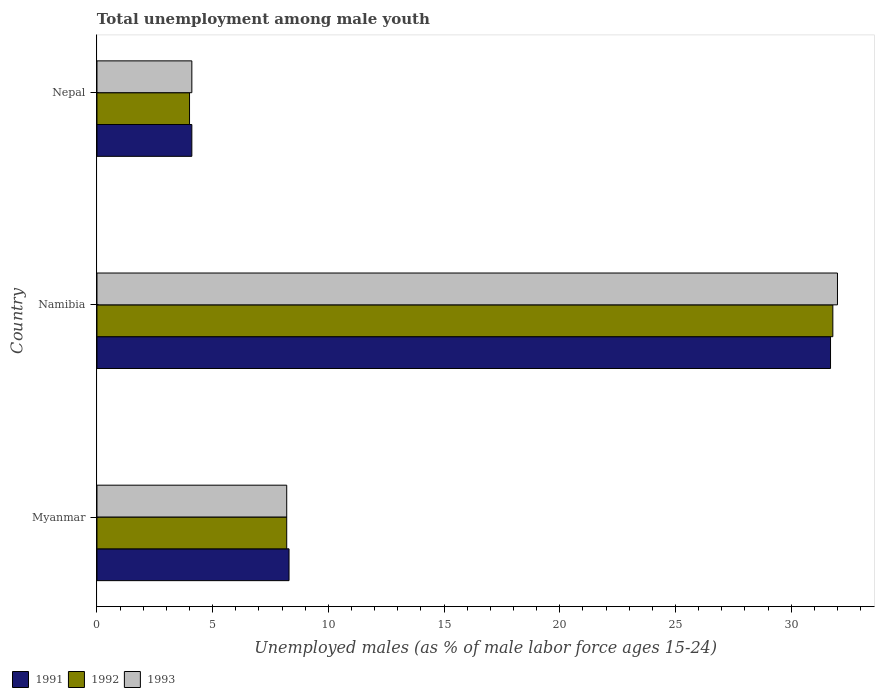How many groups of bars are there?
Your response must be concise. 3. Are the number of bars per tick equal to the number of legend labels?
Offer a very short reply. Yes. Are the number of bars on each tick of the Y-axis equal?
Provide a short and direct response. Yes. How many bars are there on the 2nd tick from the top?
Provide a succinct answer. 3. What is the label of the 2nd group of bars from the top?
Keep it short and to the point. Namibia. What is the percentage of unemployed males in in 1993 in Namibia?
Make the answer very short. 32. Across all countries, what is the minimum percentage of unemployed males in in 1991?
Offer a terse response. 4.1. In which country was the percentage of unemployed males in in 1992 maximum?
Make the answer very short. Namibia. In which country was the percentage of unemployed males in in 1993 minimum?
Give a very brief answer. Nepal. What is the total percentage of unemployed males in in 1991 in the graph?
Ensure brevity in your answer.  44.1. What is the difference between the percentage of unemployed males in in 1991 in Myanmar and that in Nepal?
Offer a terse response. 4.2. What is the difference between the percentage of unemployed males in in 1992 in Namibia and the percentage of unemployed males in in 1993 in Myanmar?
Offer a very short reply. 23.6. What is the average percentage of unemployed males in in 1993 per country?
Ensure brevity in your answer.  14.77. What is the difference between the percentage of unemployed males in in 1992 and percentage of unemployed males in in 1993 in Myanmar?
Ensure brevity in your answer.  0. In how many countries, is the percentage of unemployed males in in 1991 greater than 28 %?
Keep it short and to the point. 1. What is the ratio of the percentage of unemployed males in in 1992 in Myanmar to that in Nepal?
Offer a terse response. 2.05. What is the difference between the highest and the second highest percentage of unemployed males in in 1992?
Make the answer very short. 23.6. What is the difference between the highest and the lowest percentage of unemployed males in in 1992?
Provide a succinct answer. 27.8. Is the sum of the percentage of unemployed males in in 1992 in Namibia and Nepal greater than the maximum percentage of unemployed males in in 1993 across all countries?
Your response must be concise. Yes. What does the 3rd bar from the top in Namibia represents?
Offer a terse response. 1991. What does the 1st bar from the bottom in Namibia represents?
Your answer should be very brief. 1991. How many bars are there?
Your response must be concise. 9. How many countries are there in the graph?
Offer a very short reply. 3. Are the values on the major ticks of X-axis written in scientific E-notation?
Provide a short and direct response. No. Does the graph contain any zero values?
Ensure brevity in your answer.  No. Does the graph contain grids?
Provide a succinct answer. No. How many legend labels are there?
Provide a short and direct response. 3. How are the legend labels stacked?
Make the answer very short. Horizontal. What is the title of the graph?
Ensure brevity in your answer.  Total unemployment among male youth. Does "1990" appear as one of the legend labels in the graph?
Offer a very short reply. No. What is the label or title of the X-axis?
Provide a succinct answer. Unemployed males (as % of male labor force ages 15-24). What is the Unemployed males (as % of male labor force ages 15-24) of 1991 in Myanmar?
Your answer should be compact. 8.3. What is the Unemployed males (as % of male labor force ages 15-24) of 1992 in Myanmar?
Make the answer very short. 8.2. What is the Unemployed males (as % of male labor force ages 15-24) in 1993 in Myanmar?
Provide a short and direct response. 8.2. What is the Unemployed males (as % of male labor force ages 15-24) of 1991 in Namibia?
Your answer should be compact. 31.7. What is the Unemployed males (as % of male labor force ages 15-24) of 1992 in Namibia?
Provide a succinct answer. 31.8. What is the Unemployed males (as % of male labor force ages 15-24) of 1991 in Nepal?
Offer a terse response. 4.1. What is the Unemployed males (as % of male labor force ages 15-24) of 1993 in Nepal?
Keep it short and to the point. 4.1. Across all countries, what is the maximum Unemployed males (as % of male labor force ages 15-24) of 1991?
Give a very brief answer. 31.7. Across all countries, what is the maximum Unemployed males (as % of male labor force ages 15-24) in 1992?
Your response must be concise. 31.8. Across all countries, what is the maximum Unemployed males (as % of male labor force ages 15-24) of 1993?
Keep it short and to the point. 32. Across all countries, what is the minimum Unemployed males (as % of male labor force ages 15-24) in 1991?
Your answer should be very brief. 4.1. Across all countries, what is the minimum Unemployed males (as % of male labor force ages 15-24) in 1993?
Make the answer very short. 4.1. What is the total Unemployed males (as % of male labor force ages 15-24) of 1991 in the graph?
Provide a short and direct response. 44.1. What is the total Unemployed males (as % of male labor force ages 15-24) of 1992 in the graph?
Keep it short and to the point. 44. What is the total Unemployed males (as % of male labor force ages 15-24) of 1993 in the graph?
Your answer should be very brief. 44.3. What is the difference between the Unemployed males (as % of male labor force ages 15-24) in 1991 in Myanmar and that in Namibia?
Provide a short and direct response. -23.4. What is the difference between the Unemployed males (as % of male labor force ages 15-24) of 1992 in Myanmar and that in Namibia?
Your answer should be very brief. -23.6. What is the difference between the Unemployed males (as % of male labor force ages 15-24) of 1993 in Myanmar and that in Namibia?
Your answer should be compact. -23.8. What is the difference between the Unemployed males (as % of male labor force ages 15-24) in 1992 in Myanmar and that in Nepal?
Your response must be concise. 4.2. What is the difference between the Unemployed males (as % of male labor force ages 15-24) in 1993 in Myanmar and that in Nepal?
Offer a terse response. 4.1. What is the difference between the Unemployed males (as % of male labor force ages 15-24) in 1991 in Namibia and that in Nepal?
Your response must be concise. 27.6. What is the difference between the Unemployed males (as % of male labor force ages 15-24) of 1992 in Namibia and that in Nepal?
Make the answer very short. 27.8. What is the difference between the Unemployed males (as % of male labor force ages 15-24) of 1993 in Namibia and that in Nepal?
Ensure brevity in your answer.  27.9. What is the difference between the Unemployed males (as % of male labor force ages 15-24) in 1991 in Myanmar and the Unemployed males (as % of male labor force ages 15-24) in 1992 in Namibia?
Provide a succinct answer. -23.5. What is the difference between the Unemployed males (as % of male labor force ages 15-24) of 1991 in Myanmar and the Unemployed males (as % of male labor force ages 15-24) of 1993 in Namibia?
Provide a short and direct response. -23.7. What is the difference between the Unemployed males (as % of male labor force ages 15-24) of 1992 in Myanmar and the Unemployed males (as % of male labor force ages 15-24) of 1993 in Namibia?
Make the answer very short. -23.8. What is the difference between the Unemployed males (as % of male labor force ages 15-24) of 1991 in Myanmar and the Unemployed males (as % of male labor force ages 15-24) of 1992 in Nepal?
Make the answer very short. 4.3. What is the difference between the Unemployed males (as % of male labor force ages 15-24) in 1992 in Myanmar and the Unemployed males (as % of male labor force ages 15-24) in 1993 in Nepal?
Your response must be concise. 4.1. What is the difference between the Unemployed males (as % of male labor force ages 15-24) in 1991 in Namibia and the Unemployed males (as % of male labor force ages 15-24) in 1992 in Nepal?
Keep it short and to the point. 27.7. What is the difference between the Unemployed males (as % of male labor force ages 15-24) of 1991 in Namibia and the Unemployed males (as % of male labor force ages 15-24) of 1993 in Nepal?
Your answer should be very brief. 27.6. What is the difference between the Unemployed males (as % of male labor force ages 15-24) of 1992 in Namibia and the Unemployed males (as % of male labor force ages 15-24) of 1993 in Nepal?
Keep it short and to the point. 27.7. What is the average Unemployed males (as % of male labor force ages 15-24) of 1992 per country?
Provide a short and direct response. 14.67. What is the average Unemployed males (as % of male labor force ages 15-24) of 1993 per country?
Provide a succinct answer. 14.77. What is the difference between the Unemployed males (as % of male labor force ages 15-24) in 1991 and Unemployed males (as % of male labor force ages 15-24) in 1992 in Myanmar?
Your answer should be very brief. 0.1. What is the difference between the Unemployed males (as % of male labor force ages 15-24) in 1991 and Unemployed males (as % of male labor force ages 15-24) in 1992 in Namibia?
Keep it short and to the point. -0.1. What is the difference between the Unemployed males (as % of male labor force ages 15-24) in 1991 and Unemployed males (as % of male labor force ages 15-24) in 1993 in Namibia?
Your answer should be compact. -0.3. What is the difference between the Unemployed males (as % of male labor force ages 15-24) in 1992 and Unemployed males (as % of male labor force ages 15-24) in 1993 in Namibia?
Make the answer very short. -0.2. What is the difference between the Unemployed males (as % of male labor force ages 15-24) of 1991 and Unemployed males (as % of male labor force ages 15-24) of 1992 in Nepal?
Your response must be concise. 0.1. What is the difference between the Unemployed males (as % of male labor force ages 15-24) of 1992 and Unemployed males (as % of male labor force ages 15-24) of 1993 in Nepal?
Offer a terse response. -0.1. What is the ratio of the Unemployed males (as % of male labor force ages 15-24) of 1991 in Myanmar to that in Namibia?
Your answer should be very brief. 0.26. What is the ratio of the Unemployed males (as % of male labor force ages 15-24) in 1992 in Myanmar to that in Namibia?
Give a very brief answer. 0.26. What is the ratio of the Unemployed males (as % of male labor force ages 15-24) of 1993 in Myanmar to that in Namibia?
Offer a terse response. 0.26. What is the ratio of the Unemployed males (as % of male labor force ages 15-24) in 1991 in Myanmar to that in Nepal?
Provide a short and direct response. 2.02. What is the ratio of the Unemployed males (as % of male labor force ages 15-24) in 1992 in Myanmar to that in Nepal?
Offer a very short reply. 2.05. What is the ratio of the Unemployed males (as % of male labor force ages 15-24) of 1991 in Namibia to that in Nepal?
Provide a succinct answer. 7.73. What is the ratio of the Unemployed males (as % of male labor force ages 15-24) of 1992 in Namibia to that in Nepal?
Provide a short and direct response. 7.95. What is the ratio of the Unemployed males (as % of male labor force ages 15-24) of 1993 in Namibia to that in Nepal?
Your answer should be very brief. 7.8. What is the difference between the highest and the second highest Unemployed males (as % of male labor force ages 15-24) in 1991?
Provide a short and direct response. 23.4. What is the difference between the highest and the second highest Unemployed males (as % of male labor force ages 15-24) of 1992?
Offer a very short reply. 23.6. What is the difference between the highest and the second highest Unemployed males (as % of male labor force ages 15-24) in 1993?
Keep it short and to the point. 23.8. What is the difference between the highest and the lowest Unemployed males (as % of male labor force ages 15-24) of 1991?
Your answer should be compact. 27.6. What is the difference between the highest and the lowest Unemployed males (as % of male labor force ages 15-24) in 1992?
Offer a very short reply. 27.8. What is the difference between the highest and the lowest Unemployed males (as % of male labor force ages 15-24) in 1993?
Your answer should be very brief. 27.9. 